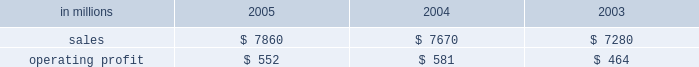Were more than offset by higher raw material and energy costs ( $ 312 million ) , increased market related downtime ( $ 187 million ) and other items ( $ 30 million ) .
Com- pared with 2003 , higher 2005 earnings in the brazilian papers , u.s .
Coated papers and u.s .
Market pulp busi- nesses were offset by lower earnings in the u.s .
Un- coated papers and the european papers businesses .
The printing papers segment took 995000 tons of downtime in 2005 , including 540000 tons of lack-of-order down- time to align production with customer demand .
This compared with 525000 tons of downtime in 2004 , of which 65000 tons related to lack-of-orders .
Printing papers in millions 2005 2004 2003 .
Uncoated papers sales totaled $ 4.8 billion in 2005 compared with $ 5.0 billion in 2004 and 2003 .
Sales price realizations in the united states averaged 4.4% ( 4.4 % ) higher in 2005 than in 2004 , and 4.6% ( 4.6 % ) higher than 2003 .
Favorable pricing momentum which began in 2004 carried over into the beginning of 2005 .
Demand , however , began to weaken across all grades as the year progressed , resulting in lower price realizations in the second and third quarters .
However , prices stabilized as the year ended .
Total shipments for the year were 7.2% ( 7.2 % ) lower than in 2004 and 4.2% ( 4.2 % ) lower than in 2003 .
To continue matching our productive capacity with customer demand , the business announced the perma- nent closure of three uncoated freesheet machines and took significant lack-of-order downtime during the period .
Demand showed some improvement toward the end of the year , bolstered by the introduction our new line of vision innovation paper products ( vip technologiestm ) , with improved brightness and white- ness .
Mill operations were favorable compared to last year , and the rebuild of the no .
1 machine at the east- over , south carolina mill was completed as planned in the fourth quarter .
However , the favorable impacts of improved mill operations and lower overhead costs were more than offset by record high input costs for energy and wood and higher transportation costs compared to 2004 .
The earnings decline in 2005 compared with 2003 was principally due to lower shipments , higher down- time and increased costs for wood , energy and trans- portation , partially offset by lower overhead costs and favorable mill operations .
Average sales price realizations for our european operations remained relatively stable during 2005 , but averaged 1% ( 1 % ) lower than in 2004 , and 6% ( 6 % ) below 2003 levels .
Sales volumes rose slightly , up 1% ( 1 % ) in 2005 com- pared with 2004 and 5% ( 5 % ) compared to 2003 .
Earnings were lower than in 2004 , reflecting higher wood and energy costs and a compression of margins due to un- favorable foreign currency exchange movements .
Earn- ings were also adversely affected by downtime related to the rebuild of three paper machines during the year .
Coated papers sales in the united states were $ 1.6 bil- lion in 2005 , compared with $ 1.4 billion in 2004 and $ 1.3 billion in 2003 .
The business reported an operating profit in 2005 versus a small operating loss in 2004 .
The earnings improvement was driven by higher average sales prices and improved mill operations .
Price realiza- tions in 2005 averaged 13% ( 13 % ) higher than 2004 .
Higher input costs for raw materials and energy partially offset the benefits from improved prices and operations .
Sales volumes were about 1% ( 1 % ) lower in 2005 versus 2004 .
Market pulp sales from our u.s .
And european facilities totaled $ 757 million in 2005 compared with $ 661 mil- lion and $ 571 million in 2004 and 2003 , respectively .
Operating profits in 2005 were up 86% ( 86 % ) from 2004 .
An operating loss had been reported in 2003 .
Higher aver- age prices and sales volumes , lower overhead costs and improved mill operations in 2005 more than offset in- creases in raw material , energy and chemical costs .
U.s .
Softwood and hardwood pulp prices improved through the 2005 first and second quarters , then declined during the third quarter , but recovered somewhat toward year end .
Softwood pulp prices ended the year about 2% ( 2 % ) lower than 2004 , but were 15% ( 15 % ) higher than 2003 , while hardwood pulp prices ended the year about 15% ( 15 % ) higher than 2004 and 10% ( 10 % ) higher than 2003 .
U.s .
Pulp sales volumes were 12% ( 12 % ) higher than in 2004 and 19% ( 19 % ) higher than in 2003 , reflecting increased global demand .
Euro- pean pulp volumes increased 15% ( 15 % ) and 2% ( 2 % ) compared with 2004 and 2003 , respectively , while average sales prices increased 4% ( 4 % ) and 11% ( 11 % ) compared with 2004 and 2003 , respectively .
Brazilian paper sales were $ 684 million in 2005 com- pared with $ 592 million in 2004 and $ 540 million in 2003 .
Sales volumes for uncoated freesheet paper , coated paper and wood chips were down from 2004 , but average price realizations improved for exported un- coated freesheet and coated groundwood paper grades .
Favorable currency translation , as yearly average real exchange rates versus the u.s .
Dollar were 17% ( 17 % ) higher in 2005 than in 2004 , positively impacted reported sales in u.s .
Dollars .
Average sales prices for domestic un- coated paper declined 4% ( 4 % ) in local currency versus 2004 , while domestic coated paper prices were down 3% ( 3 % ) .
Operating profits in 2005 were down 9% ( 9 % ) from 2004 , but were up 2% ( 2 % ) from 2003 .
Earnings in 2005 were neg- atively impacted by a weaker product and geographic sales mix for both uncoated and coated papers , reflecting increased competition and softer demand , particularly in the printing , commercial and editorial market segments. .
What was the printing papers profit margin in 2003? 
Computations: (464 / 7280)
Answer: 0.06374. 